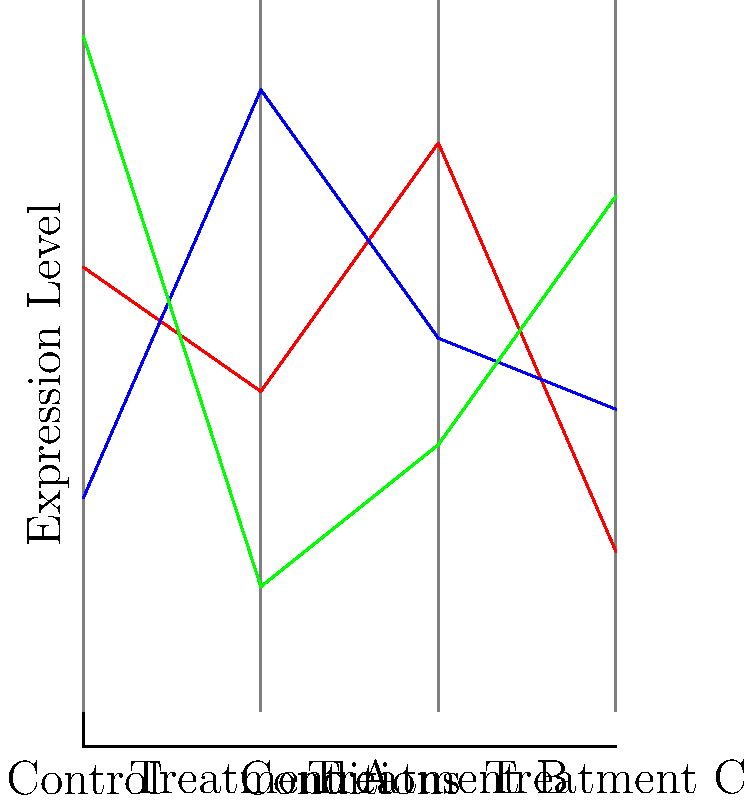In the parallel coordinate plot of gene expression data shown above, which gene exhibits the most significant upregulation in Treatment B compared to the Control condition, and what is the approximate fold change? To answer this question, we need to follow these steps:

1. Identify the expression levels for each gene in the Control and Treatment B conditions:
   Gene A: Control ≈ 2.5, Treatment B ≈ 3.2
   Gene B: Control ≈ 1.2, Treatment B ≈ 2.1
   Gene C: Control ≈ 3.8, Treatment B ≈ 1.5

2. Calculate the fold change for each gene:
   Fold change = Expression in Treatment B / Expression in Control

   Gene A: 3.2 / 2.5 ≈ 1.28
   Gene B: 2.1 / 1.2 ≈ 1.75
   Gene C: 1.5 / 3.8 ≈ 0.39 (downregulation)

3. Compare the fold changes:
   Gene B has the highest fold change (1.75) among the upregulated genes.

4. Convert the fold change to an approximate value:
   1.75 is approximately a 1.8-fold increase.

Therefore, Gene B shows the most significant upregulation in Treatment B compared to the Control condition, with an approximate 1.8-fold increase in expression.
Answer: Gene B, ≈1.8-fold increase 